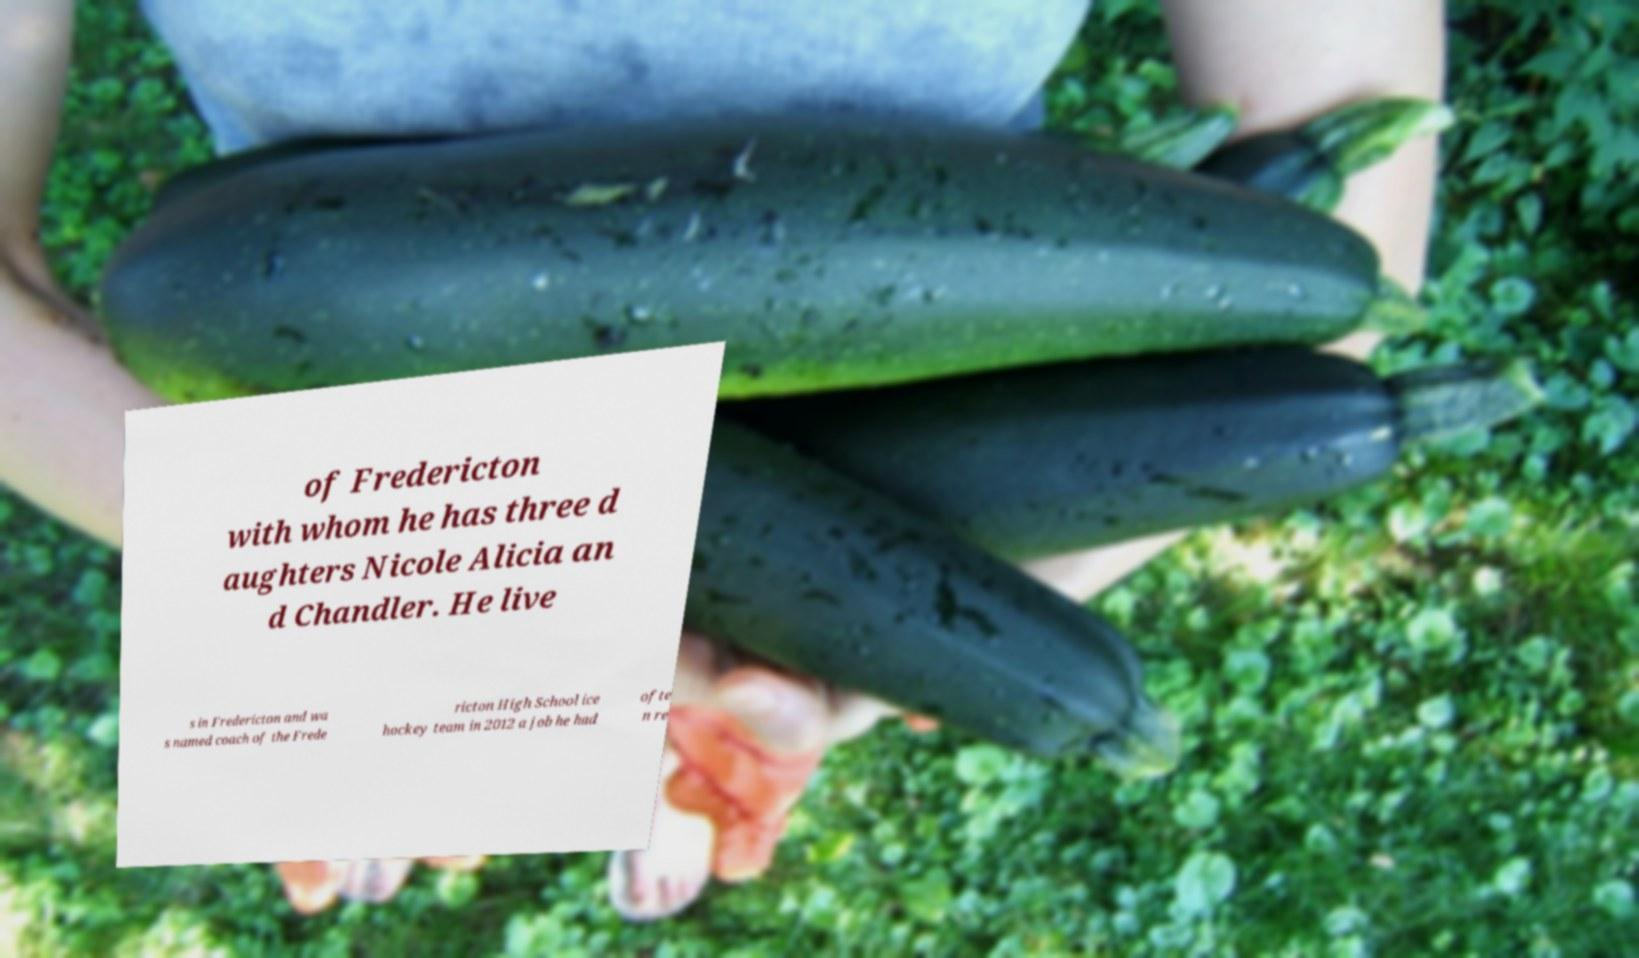For documentation purposes, I need the text within this image transcribed. Could you provide that? of Fredericton with whom he has three d aughters Nicole Alicia an d Chandler. He live s in Fredericton and wa s named coach of the Frede ricton High School ice hockey team in 2012 a job he had ofte n re 